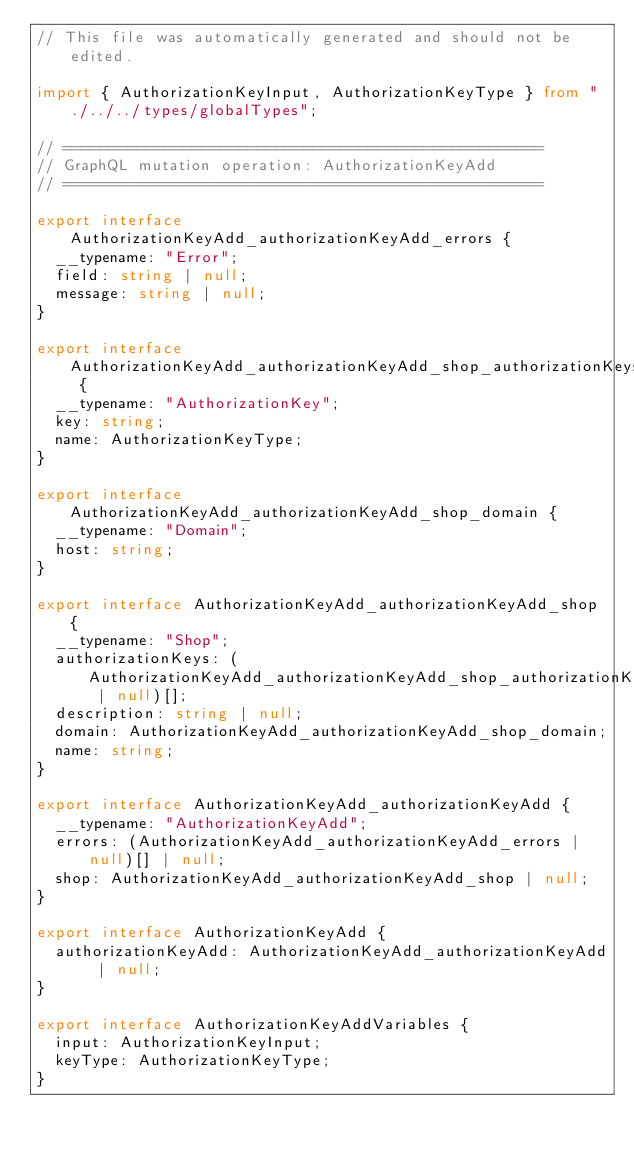Convert code to text. <code><loc_0><loc_0><loc_500><loc_500><_TypeScript_>// This file was automatically generated and should not be edited.

import { AuthorizationKeyInput, AuthorizationKeyType } from "./../../types/globalTypes";

// ====================================================
// GraphQL mutation operation: AuthorizationKeyAdd
// ====================================================

export interface AuthorizationKeyAdd_authorizationKeyAdd_errors {
  __typename: "Error";
  field: string | null;
  message: string | null;
}

export interface AuthorizationKeyAdd_authorizationKeyAdd_shop_authorizationKeys {
  __typename: "AuthorizationKey";
  key: string;
  name: AuthorizationKeyType;
}

export interface AuthorizationKeyAdd_authorizationKeyAdd_shop_domain {
  __typename: "Domain";
  host: string;
}

export interface AuthorizationKeyAdd_authorizationKeyAdd_shop {
  __typename: "Shop";
  authorizationKeys: (AuthorizationKeyAdd_authorizationKeyAdd_shop_authorizationKeys | null)[];
  description: string | null;
  domain: AuthorizationKeyAdd_authorizationKeyAdd_shop_domain;
  name: string;
}

export interface AuthorizationKeyAdd_authorizationKeyAdd {
  __typename: "AuthorizationKeyAdd";
  errors: (AuthorizationKeyAdd_authorizationKeyAdd_errors | null)[] | null;
  shop: AuthorizationKeyAdd_authorizationKeyAdd_shop | null;
}

export interface AuthorizationKeyAdd {
  authorizationKeyAdd: AuthorizationKeyAdd_authorizationKeyAdd | null;
}

export interface AuthorizationKeyAddVariables {
  input: AuthorizationKeyInput;
  keyType: AuthorizationKeyType;
}
</code> 